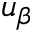Convert formula to latex. <formula><loc_0><loc_0><loc_500><loc_500>u _ { \beta }</formula> 